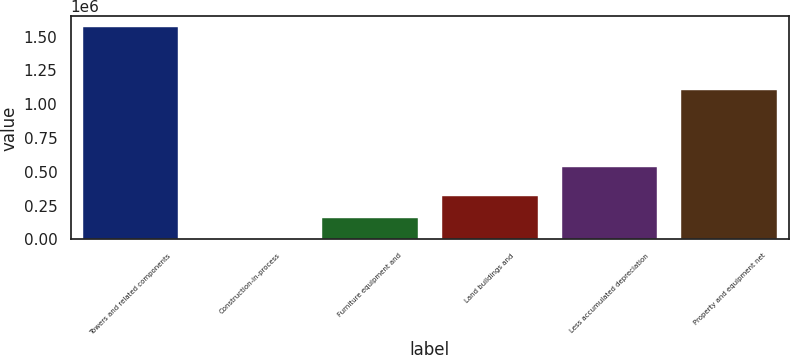Convert chart. <chart><loc_0><loc_0><loc_500><loc_500><bar_chart><fcel>Towers and related components<fcel>Construction-in-process<fcel>Furniture equipment and<fcel>Land buildings and<fcel>Less accumulated depreciation<fcel>Property and equipment net<nl><fcel>1.57134e+06<fcel>4555<fcel>161234<fcel>317912<fcel>538291<fcel>1.10594e+06<nl></chart> 